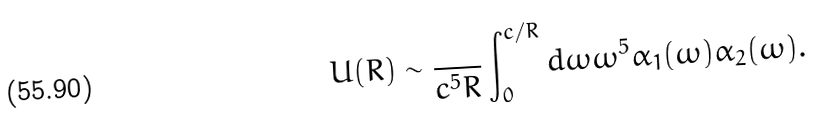<formula> <loc_0><loc_0><loc_500><loc_500>U ( R ) \sim \frac { } { c ^ { 5 } R } \int _ { 0 } ^ { c / R } d \omega \omega ^ { 5 } \alpha _ { 1 } ( \omega ) \alpha _ { 2 } ( \omega ) .</formula> 